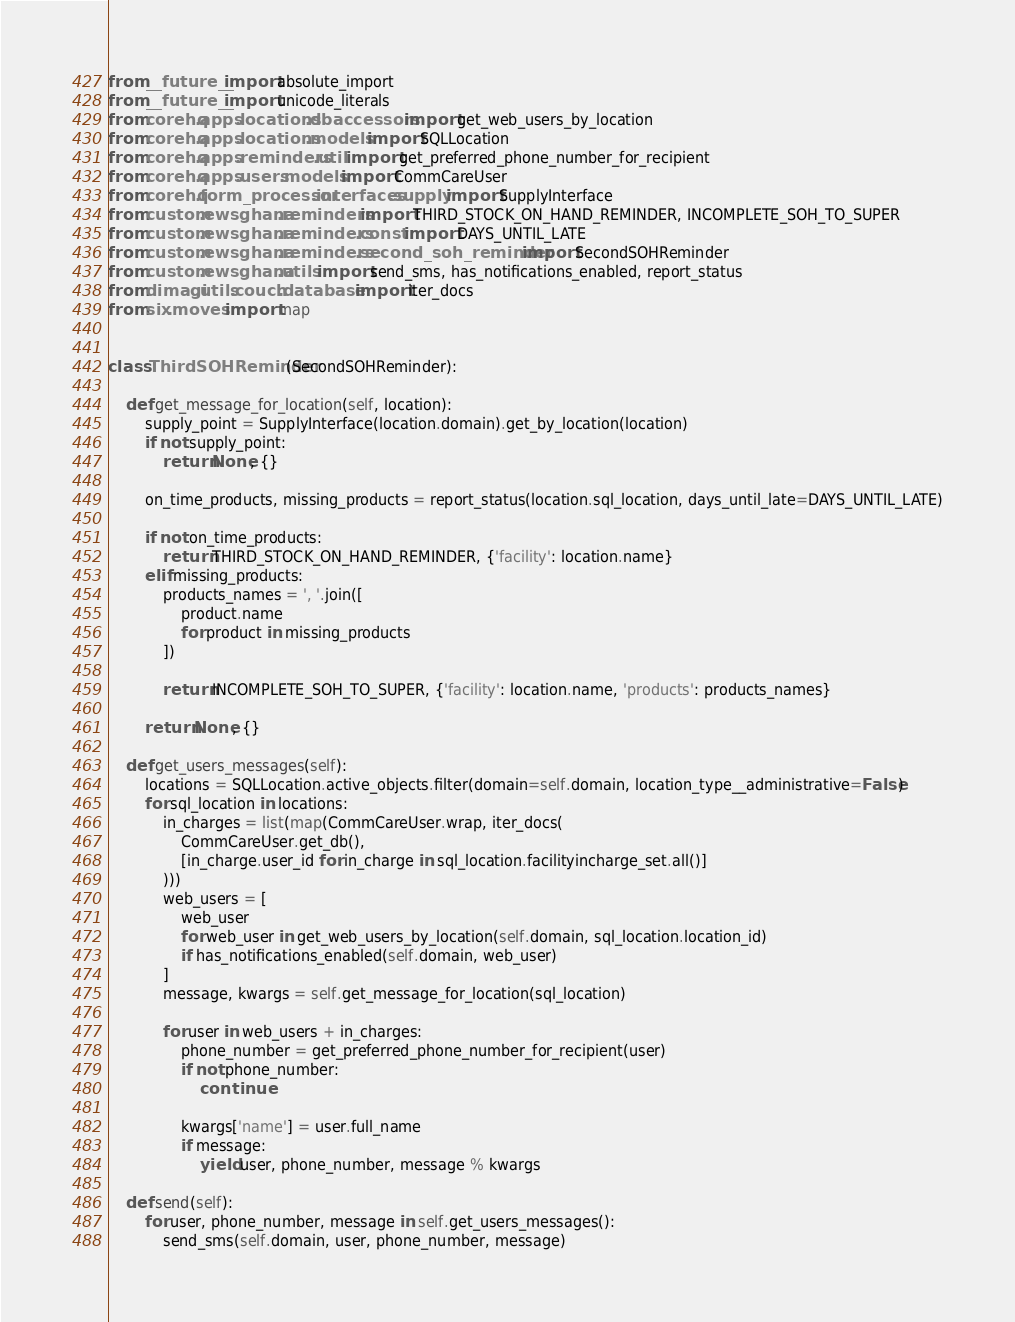Convert code to text. <code><loc_0><loc_0><loc_500><loc_500><_Python_>from __future__ import absolute_import
from __future__ import unicode_literals
from corehq.apps.locations.dbaccessors import get_web_users_by_location
from corehq.apps.locations.models import SQLLocation
from corehq.apps.reminders.util import get_preferred_phone_number_for_recipient
from corehq.apps.users.models import CommCareUser
from corehq.form_processor.interfaces.supply import SupplyInterface
from custom.ewsghana.reminders import THIRD_STOCK_ON_HAND_REMINDER, INCOMPLETE_SOH_TO_SUPER
from custom.ewsghana.reminders.const import DAYS_UNTIL_LATE
from custom.ewsghana.reminders.second_soh_reminder import SecondSOHReminder
from custom.ewsghana.utils import send_sms, has_notifications_enabled, report_status
from dimagi.utils.couch.database import iter_docs
from six.moves import map


class ThirdSOHReminder(SecondSOHReminder):

    def get_message_for_location(self, location):
        supply_point = SupplyInterface(location.domain).get_by_location(location)
        if not supply_point:
            return None, {}

        on_time_products, missing_products = report_status(location.sql_location, days_until_late=DAYS_UNTIL_LATE)

        if not on_time_products:
            return THIRD_STOCK_ON_HAND_REMINDER, {'facility': location.name}
        elif missing_products:
            products_names = ', '.join([
                product.name
                for product in missing_products
            ])

            return INCOMPLETE_SOH_TO_SUPER, {'facility': location.name, 'products': products_names}

        return None, {}

    def get_users_messages(self):
        locations = SQLLocation.active_objects.filter(domain=self.domain, location_type__administrative=False)
        for sql_location in locations:
            in_charges = list(map(CommCareUser.wrap, iter_docs(
                CommCareUser.get_db(),
                [in_charge.user_id for in_charge in sql_location.facilityincharge_set.all()]
            )))
            web_users = [
                web_user
                for web_user in get_web_users_by_location(self.domain, sql_location.location_id)
                if has_notifications_enabled(self.domain, web_user)
            ]
            message, kwargs = self.get_message_for_location(sql_location)

            for user in web_users + in_charges:
                phone_number = get_preferred_phone_number_for_recipient(user)
                if not phone_number:
                    continue

                kwargs['name'] = user.full_name
                if message:
                    yield user, phone_number, message % kwargs

    def send(self):
        for user, phone_number, message in self.get_users_messages():
            send_sms(self.domain, user, phone_number, message)
</code> 